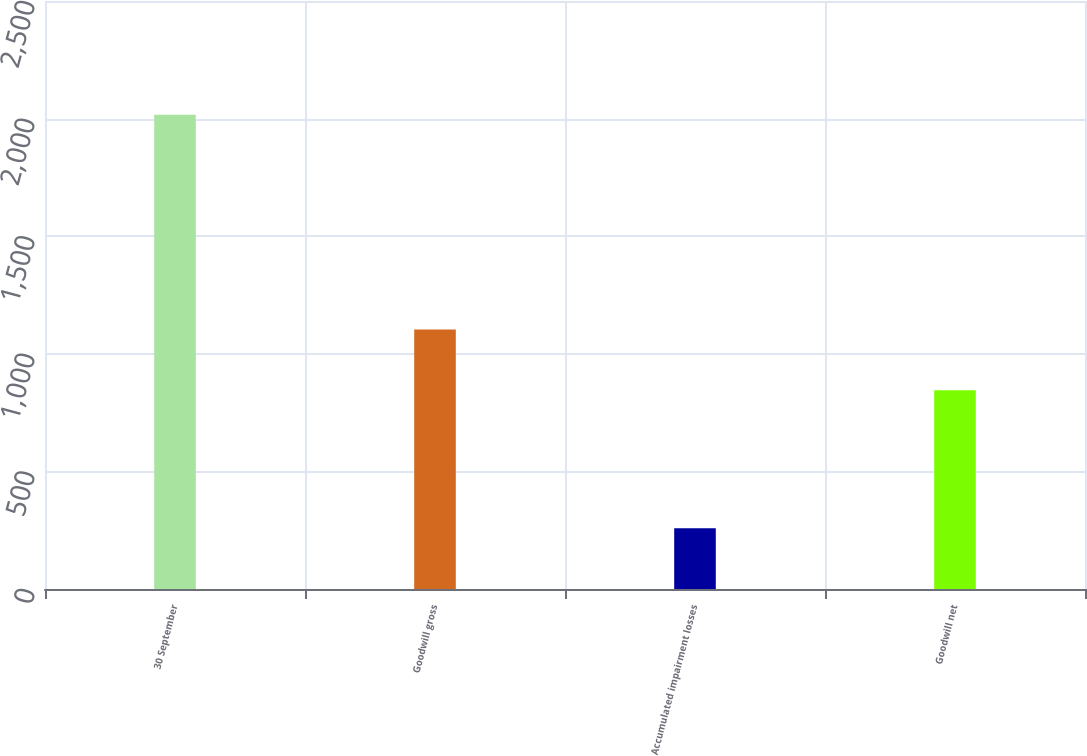Convert chart to OTSL. <chart><loc_0><loc_0><loc_500><loc_500><bar_chart><fcel>30 September<fcel>Goodwill gross<fcel>Accumulated impairment losses<fcel>Goodwill net<nl><fcel>2016<fcel>1103.7<fcel>258.6<fcel>845.1<nl></chart> 